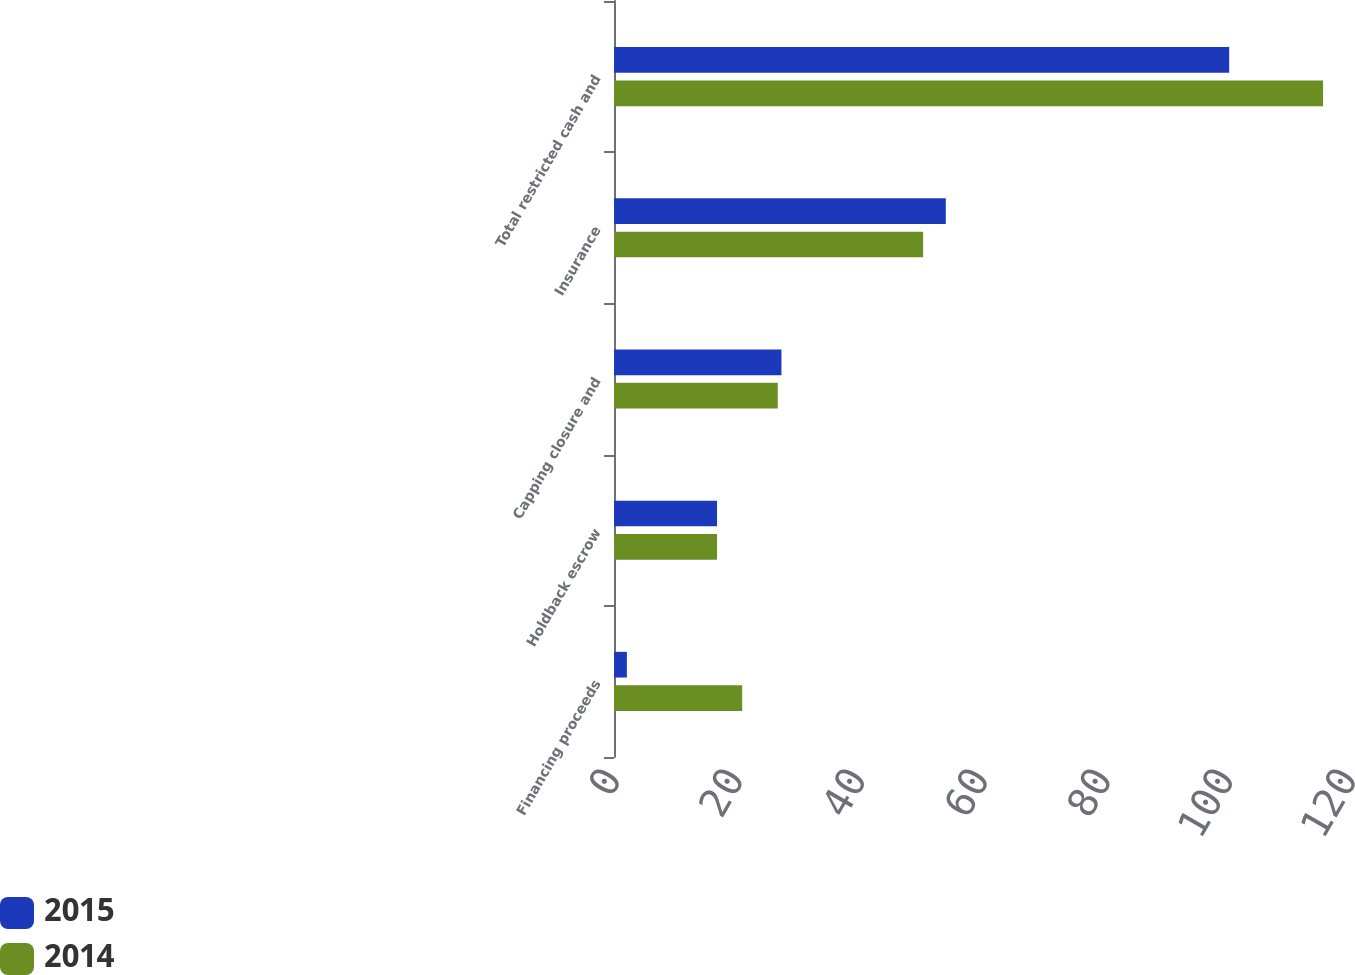Convert chart to OTSL. <chart><loc_0><loc_0><loc_500><loc_500><stacked_bar_chart><ecel><fcel>Financing proceeds<fcel>Holdback escrow<fcel>Capping closure and<fcel>Insurance<fcel>Total restricted cash and<nl><fcel>2015<fcel>2.1<fcel>16.8<fcel>27.3<fcel>54.1<fcel>100.3<nl><fcel>2014<fcel>20.9<fcel>16.8<fcel>26.7<fcel>50.4<fcel>115.6<nl></chart> 